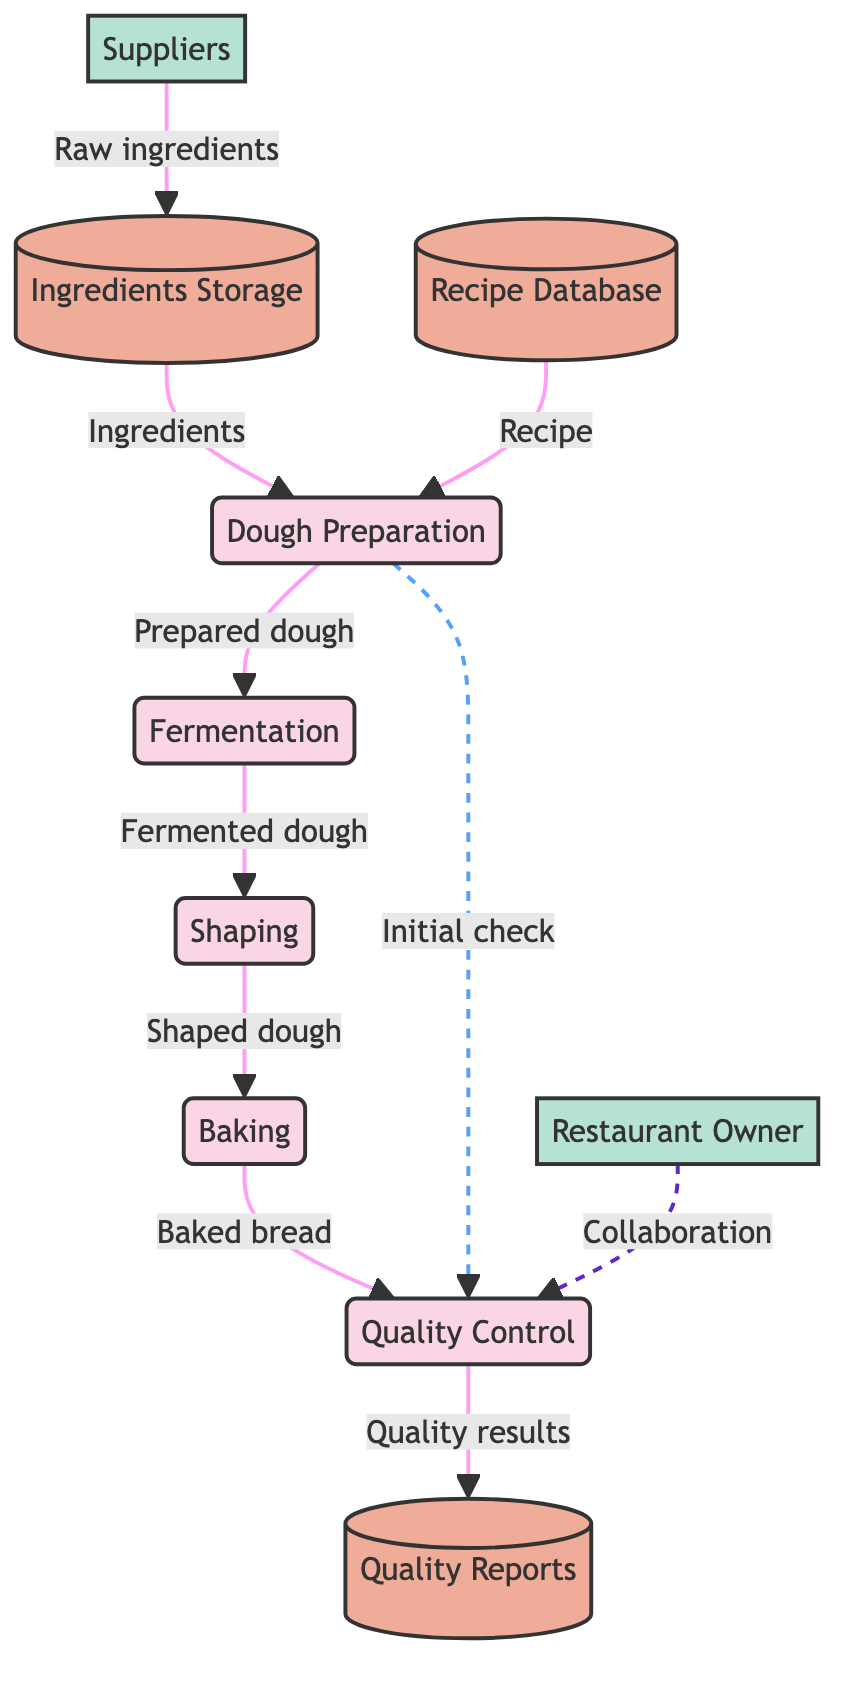What is the first process in the diagram? The first process listed in the data under "processes" is "Dough Preparation." This is identified as the starting point for the flow of operations in the bread production process.
Answer: Dough Preparation How many data flows are present in the diagram? By counting the entries under "data_flows," there are eight distinct data flows connecting various processes and stores in the diagram.
Answer: 8 Which external entity supplies raw ingredients? The external entity associated with providing raw ingredients is labeled "Suppliers" in the diagram, highlighted under "external_entities."
Answer: Suppliers What does the "Quality Control" process do? The "Quality Control" process is responsible for checking the quality of the finished bread, as described in its definition within the processes section.
Answer: Checking the quality of the finished bread Where is the prepared dough moved after "Dough Preparation"? According to the data flows, the prepared dough from "Dough Preparation" is moved to the "Fermentation" process, demonstrating the sequence of operations.
Answer: Fermentation What does the dashed line from "Dough Preparation" to "Quality Control" signify? The dashed line indicates an initial quality check occurring during the dough preparation stage, which is distinct from the final quality control performed later in the process.
Answer: Initial quality check What data store holds the recipe details? The data store responsible for holding the recipe details is labeled "Recipe Database," as indicated in the description of the data stores.
Answer: Recipe Database Which process follows "Fermentation" in the production sequence? The process that immediately follows "Fermentation" is "Shaping," which is reflected in the sequence of data flows connecting these two processes.
Answer: Shaping What is the result of the final process "Baking"? The result of the "Baking" process is "Baked bread," which is the output that moves on to the next process in the production line.
Answer: Baked bread 